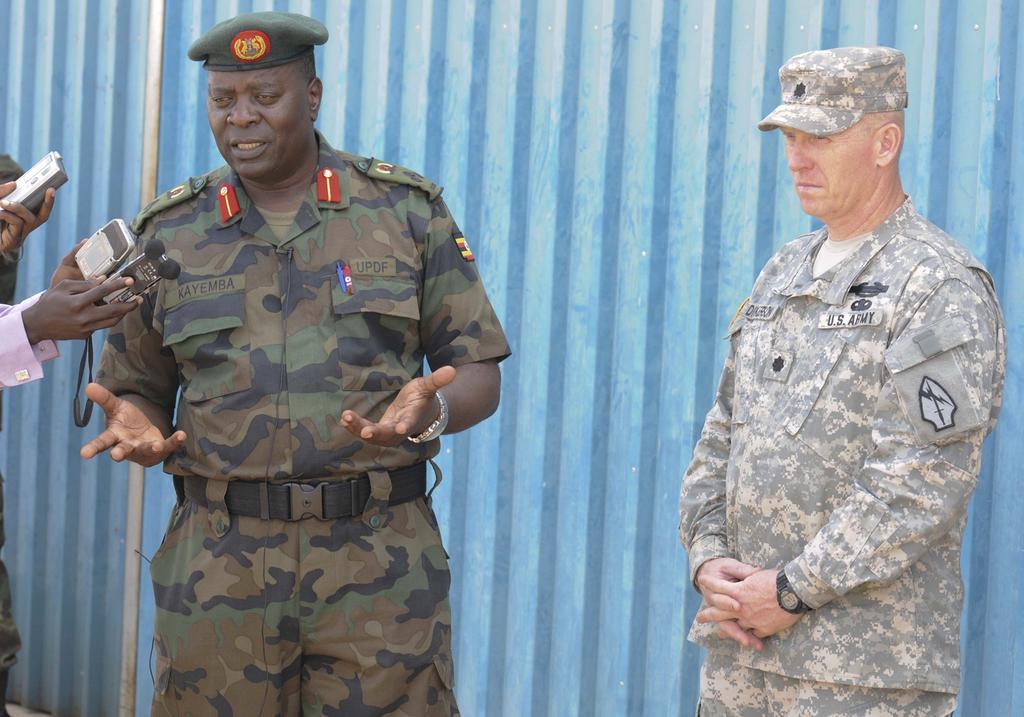In one or two sentences, can you explain what this image depicts? In this image, we can see a few people wearing dress and standing. Among them, some people are holding objects. We can also see a wall. 